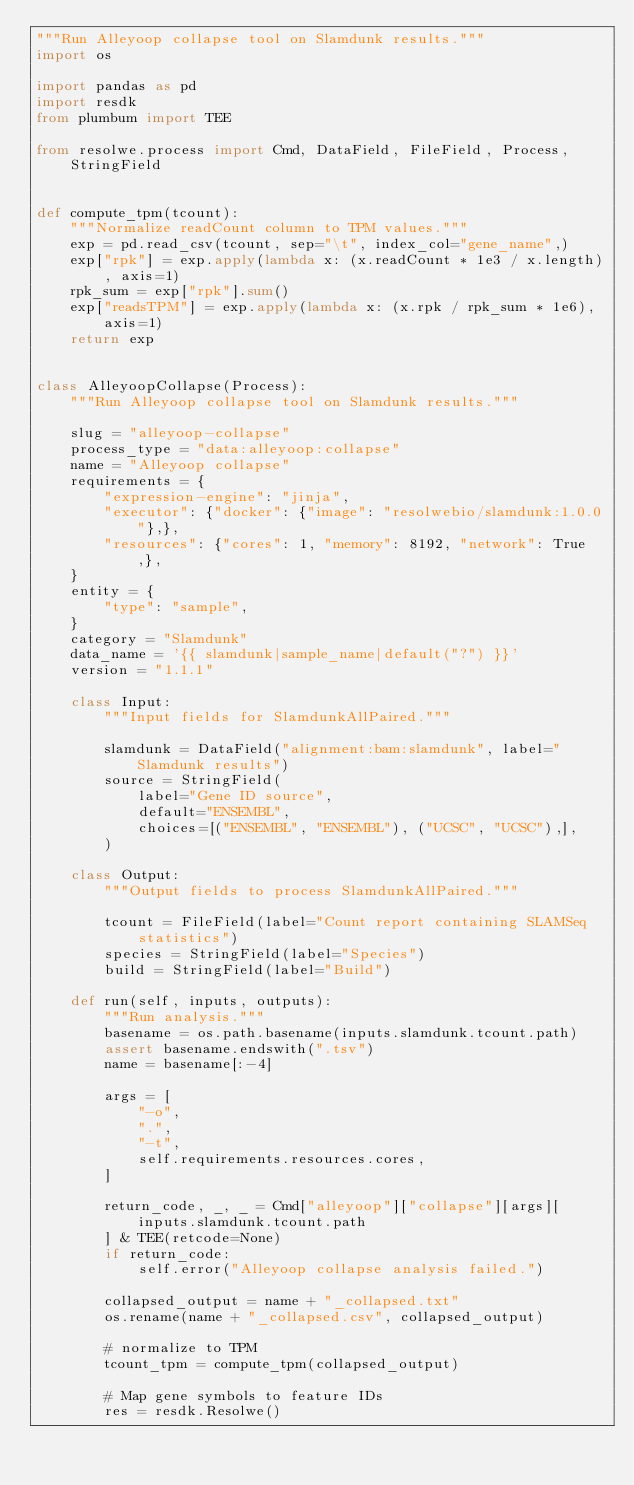Convert code to text. <code><loc_0><loc_0><loc_500><loc_500><_Python_>"""Run Alleyoop collapse tool on Slamdunk results."""
import os

import pandas as pd
import resdk
from plumbum import TEE

from resolwe.process import Cmd, DataField, FileField, Process, StringField


def compute_tpm(tcount):
    """Normalize readCount column to TPM values."""
    exp = pd.read_csv(tcount, sep="\t", index_col="gene_name",)
    exp["rpk"] = exp.apply(lambda x: (x.readCount * 1e3 / x.length), axis=1)
    rpk_sum = exp["rpk"].sum()
    exp["readsTPM"] = exp.apply(lambda x: (x.rpk / rpk_sum * 1e6), axis=1)
    return exp


class AlleyoopCollapse(Process):
    """Run Alleyoop collapse tool on Slamdunk results."""

    slug = "alleyoop-collapse"
    process_type = "data:alleyoop:collapse"
    name = "Alleyoop collapse"
    requirements = {
        "expression-engine": "jinja",
        "executor": {"docker": {"image": "resolwebio/slamdunk:1.0.0"},},
        "resources": {"cores": 1, "memory": 8192, "network": True,},
    }
    entity = {
        "type": "sample",
    }
    category = "Slamdunk"
    data_name = '{{ slamdunk|sample_name|default("?") }}'
    version = "1.1.1"

    class Input:
        """Input fields for SlamdunkAllPaired."""

        slamdunk = DataField("alignment:bam:slamdunk", label="Slamdunk results")
        source = StringField(
            label="Gene ID source",
            default="ENSEMBL",
            choices=[("ENSEMBL", "ENSEMBL"), ("UCSC", "UCSC"),],
        )

    class Output:
        """Output fields to process SlamdunkAllPaired."""

        tcount = FileField(label="Count report containing SLAMSeq statistics")
        species = StringField(label="Species")
        build = StringField(label="Build")

    def run(self, inputs, outputs):
        """Run analysis."""
        basename = os.path.basename(inputs.slamdunk.tcount.path)
        assert basename.endswith(".tsv")
        name = basename[:-4]

        args = [
            "-o",
            ".",
            "-t",
            self.requirements.resources.cores,
        ]

        return_code, _, _ = Cmd["alleyoop"]["collapse"][args][
            inputs.slamdunk.tcount.path
        ] & TEE(retcode=None)
        if return_code:
            self.error("Alleyoop collapse analysis failed.")

        collapsed_output = name + "_collapsed.txt"
        os.rename(name + "_collapsed.csv", collapsed_output)

        # normalize to TPM
        tcount_tpm = compute_tpm(collapsed_output)

        # Map gene symbols to feature IDs
        res = resdk.Resolwe()</code> 